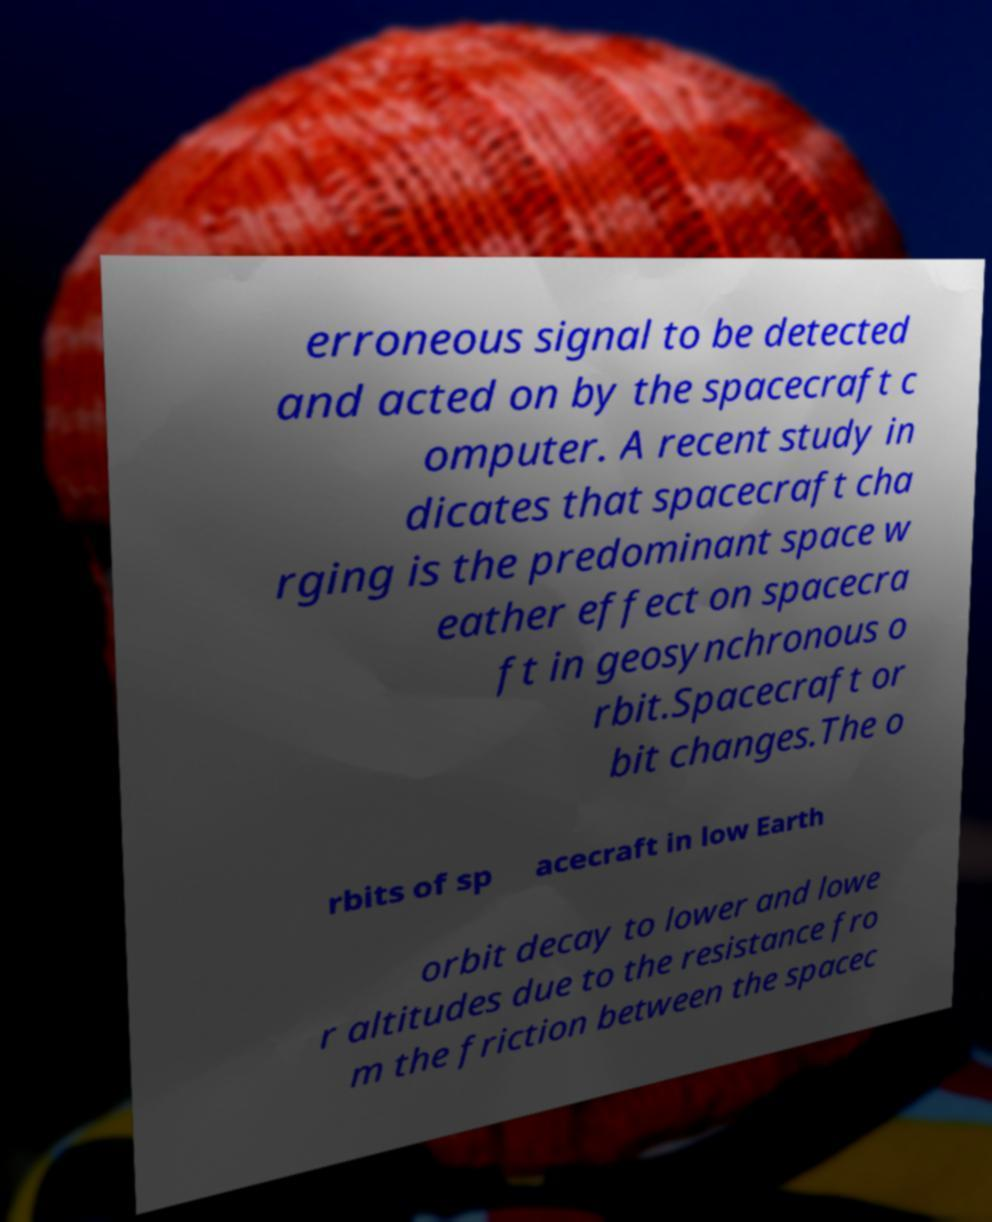Can you read and provide the text displayed in the image?This photo seems to have some interesting text. Can you extract and type it out for me? erroneous signal to be detected and acted on by the spacecraft c omputer. A recent study in dicates that spacecraft cha rging is the predominant space w eather effect on spacecra ft in geosynchronous o rbit.Spacecraft or bit changes.The o rbits of sp acecraft in low Earth orbit decay to lower and lowe r altitudes due to the resistance fro m the friction between the spacec 